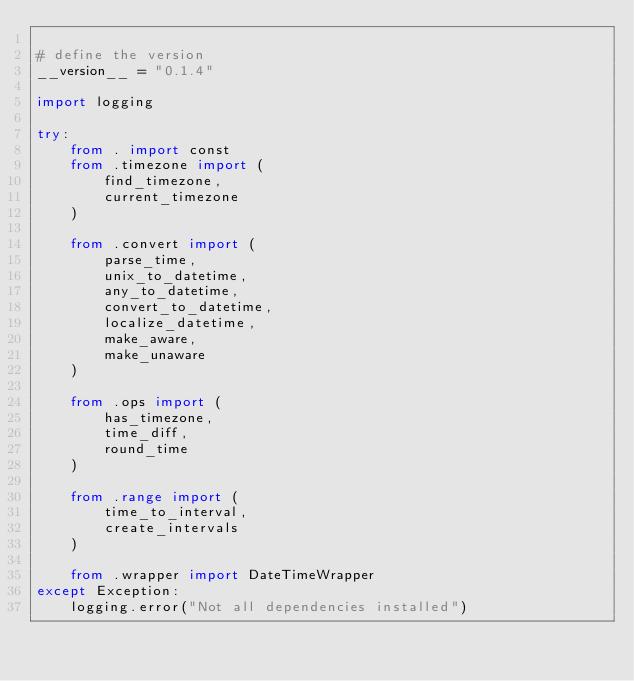Convert code to text. <code><loc_0><loc_0><loc_500><loc_500><_Python_>
# define the version
__version__ = "0.1.4"

import logging

try:
    from . import const
    from .timezone import (
        find_timezone,
        current_timezone
    )

    from .convert import (
        parse_time,
        unix_to_datetime,
        any_to_datetime,
        convert_to_datetime,
        localize_datetime,
        make_aware,
        make_unaware
    )

    from .ops import (
        has_timezone,
        time_diff,
        round_time
    )

    from .range import (
        time_to_interval,
        create_intervals
    )

    from .wrapper import DateTimeWrapper
except Exception:
    logging.error("Not all dependencies installed")

</code> 